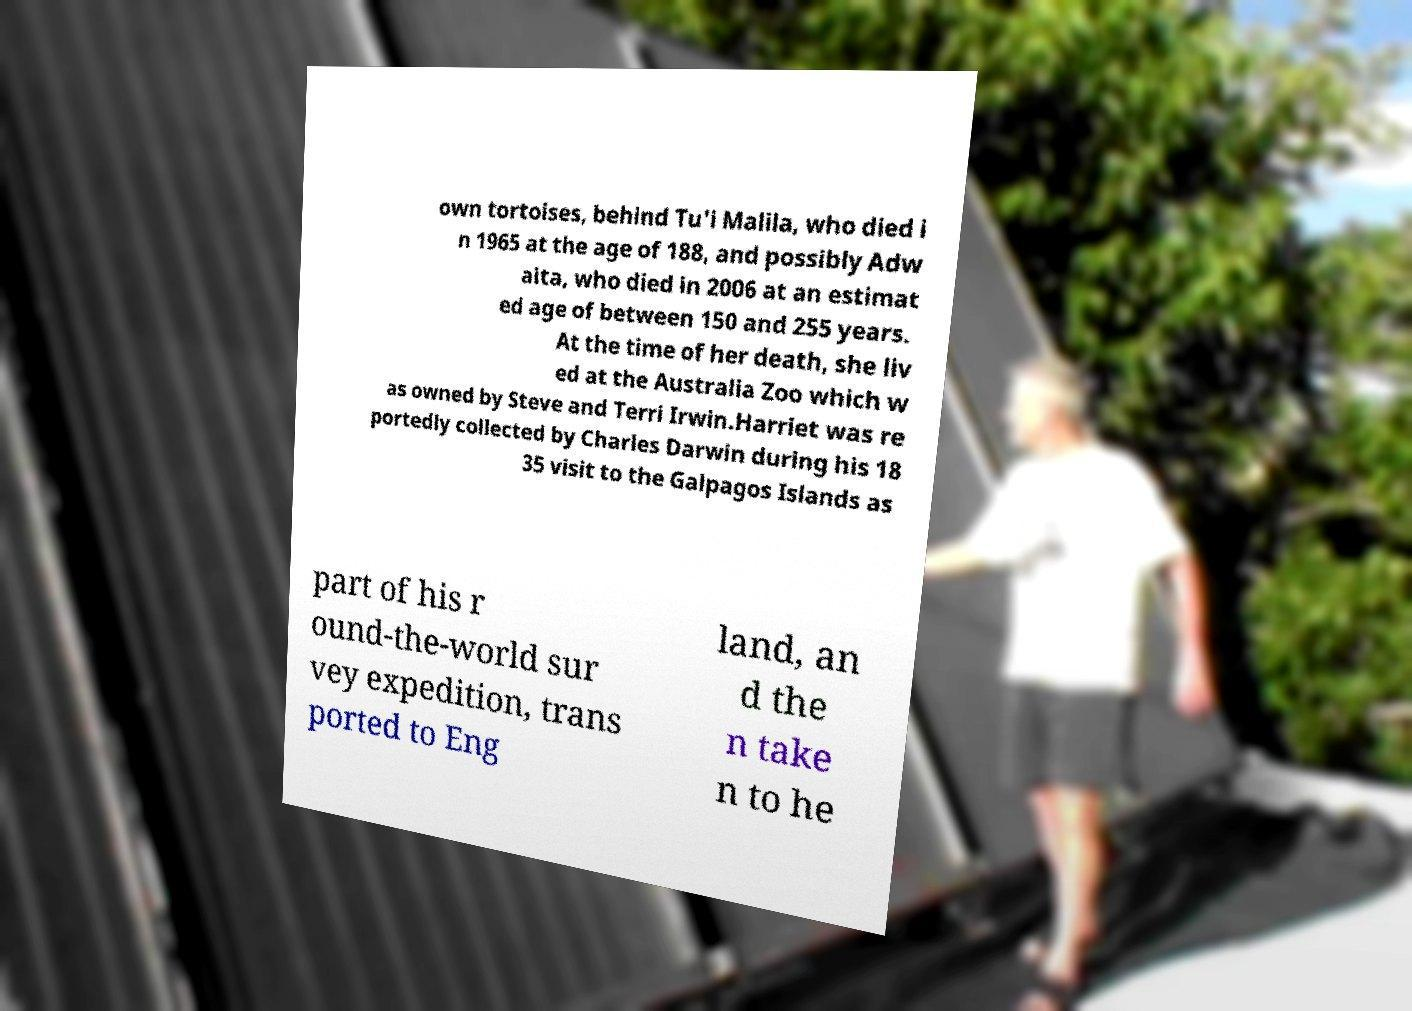Can you read and provide the text displayed in the image?This photo seems to have some interesting text. Can you extract and type it out for me? own tortoises, behind Tu'i Malila, who died i n 1965 at the age of 188, and possibly Adw aita, who died in 2006 at an estimat ed age of between 150 and 255 years. At the time of her death, she liv ed at the Australia Zoo which w as owned by Steve and Terri Irwin.Harriet was re portedly collected by Charles Darwin during his 18 35 visit to the Galpagos Islands as part of his r ound-the-world sur vey expedition, trans ported to Eng land, an d the n take n to he 